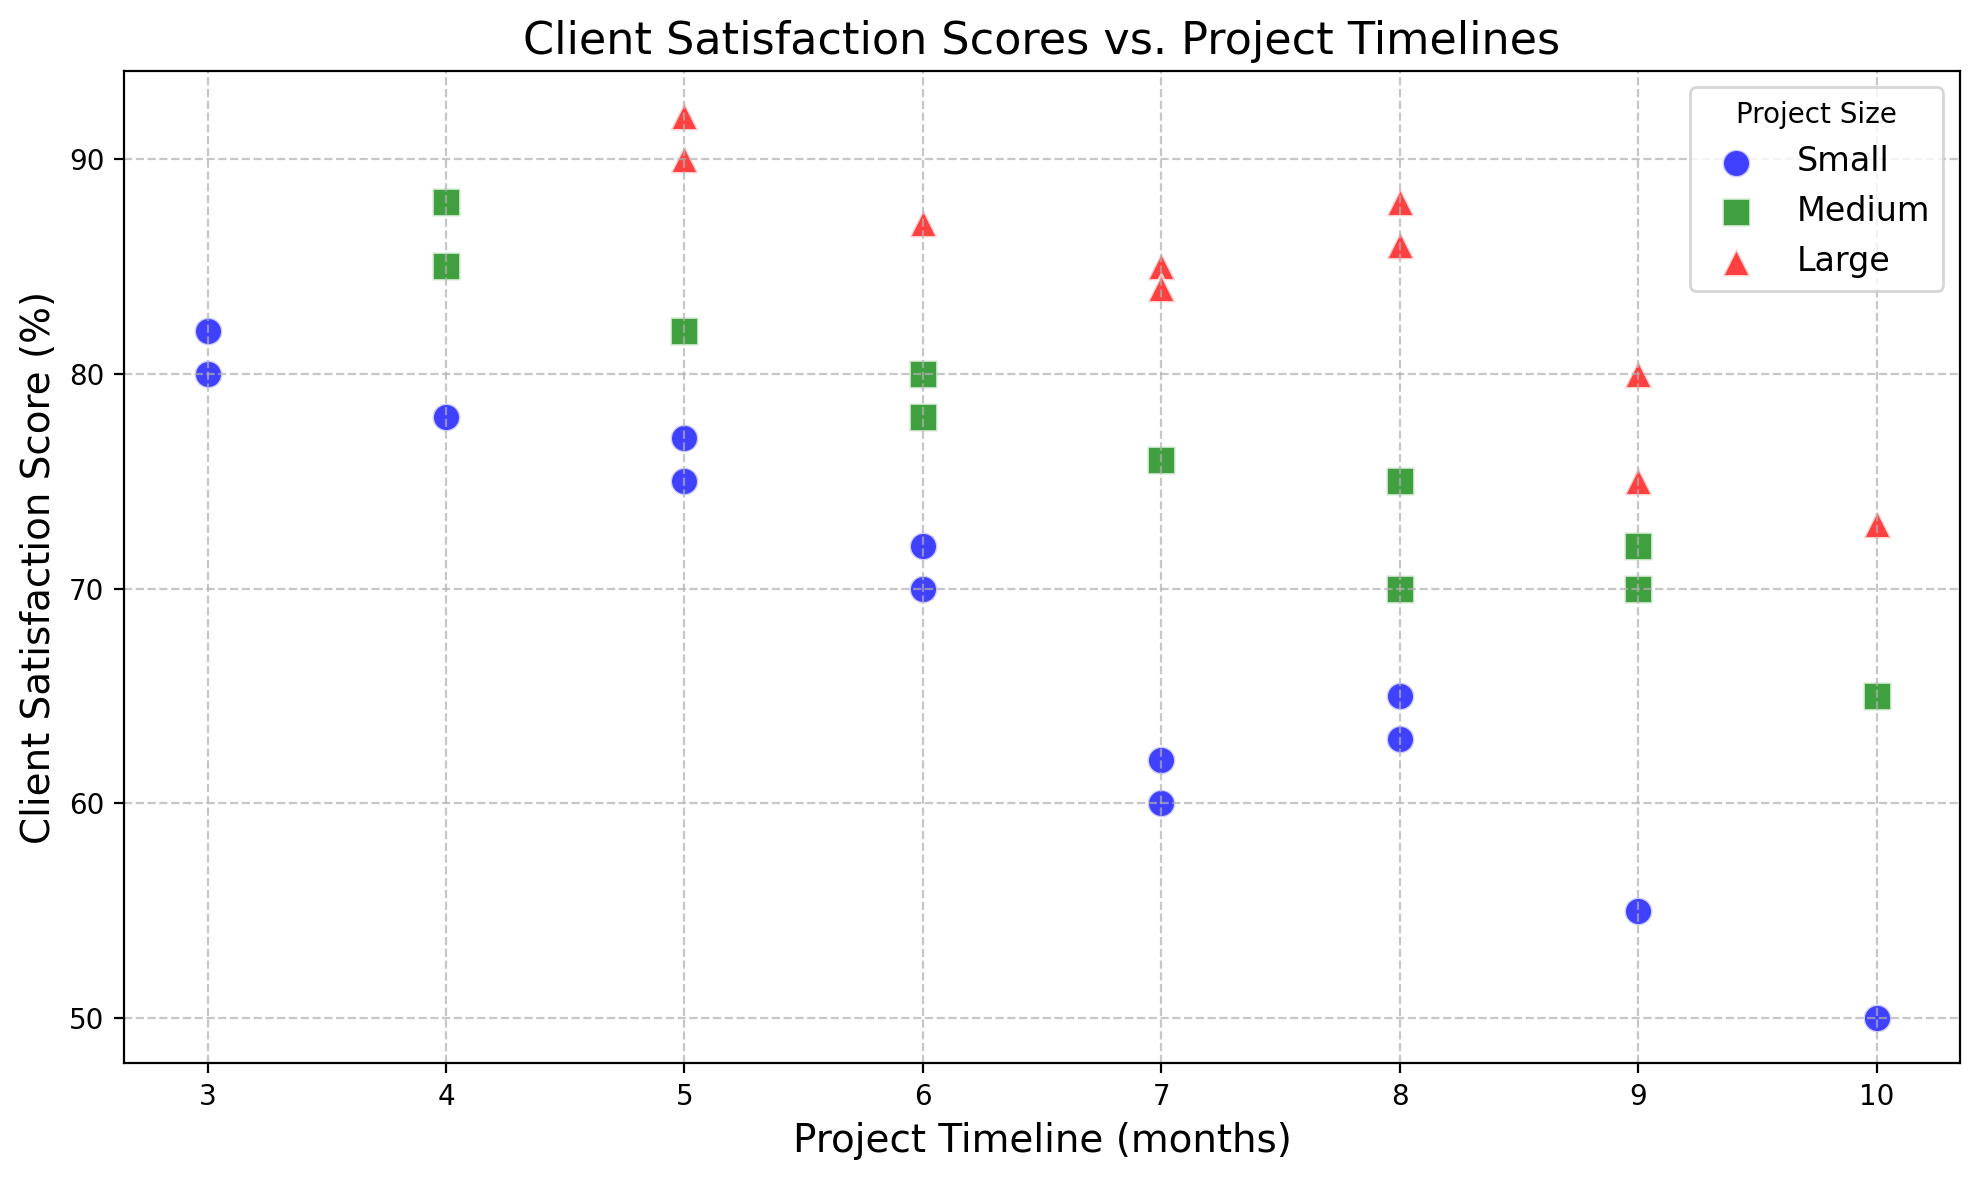Which project size generally has projects completed in the shortest timeline? The scatter plot differentiates project sizes by color and marker. Small projects are represented by blue circles, Medium by green squares, and Large by red triangles. Observing the x-axis (Project Timeline), Small projects tend to have shorter timelines compared to Medium and Large projects.
Answer: Small What is the client satisfaction score for the largest project timeline among Small projects? Look for the blue circle (Small projects) with the largest x-axis value (timeline). The largest timeline for Small projects is 10 months, with a client satisfaction score of 50.
Answer: 50 Which project size has the highest client satisfaction score overall? Identify the color/marker with the highest point on the y-axis (Client Satisfaction Score). The highest client satisfaction score is 92, represented by a red triangle which denotes Large projects.
Answer: Large How does the client satisfaction score generally trend as the project timeline increases for Medium projects? Observe the green squares' pattern as the project timeline increases. There's a general downward trend in client satisfaction scores as the project timeline increases for Medium projects.
Answer: Downward If you combine the highest client satisfaction scores for each project size, what is the result? Identify and sum the highest client satisfaction scores for Small (82), Medium (88), and Large (92) projects. 82 + 88 + 92 = 262.
Answer: 262 Are there any project sizes with consistently high satisfaction scores (above 80) regardless of the timeline? Look for any colors/markers consistently above the y-axis value of 80. No project size consistently has scores above 80 regardless of the timeline, but Large projects generally have higher scores compared to others.
Answer: No Which project size shows the most variation in client satisfaction scores? Look for the color/marker that has the widest spread along the y-axis. Small projects (blue circles) have a wide range of client satisfaction scores, varying from 50 to 82.
Answer: Small What is the client satisfaction score of the shortest timeline for Large projects? Look for the red triangle (Large projects) with the smallest x-axis value (timeline). The shortest timeline for Large projects is 5 months, with a client satisfaction score of 90.
Answer: 90 Comparing Small and Medium projects, which generally finish in a shorter timeline with higher satisfaction? Compare the blue circles (Small) and green squares (Medium) on both x-axis (timeline) and y-axis (satisfaction score). Small projects typically finish in shorter timelines and several have satisfaction scores above 75, while Medium projects show a gradual decline as the timeline increases.
Answer: Small 